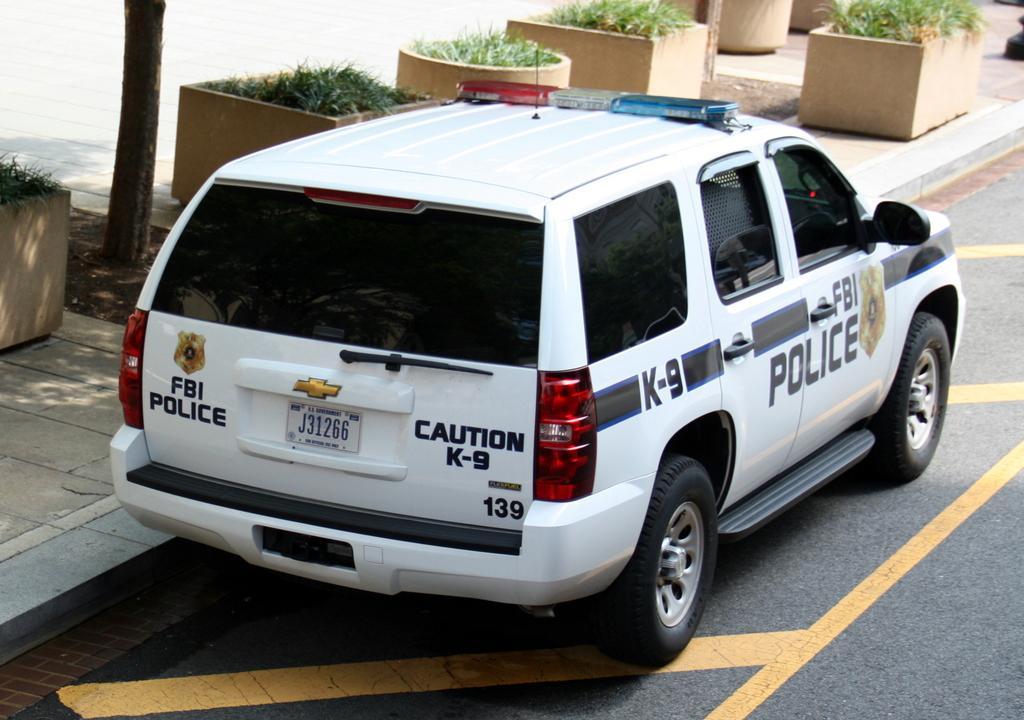Can you describe this image briefly? In this image, we can see a car is parked on the road. On the road, we can see few yellow lines. Background we can see plants with pots, walkway and tree trunk. 